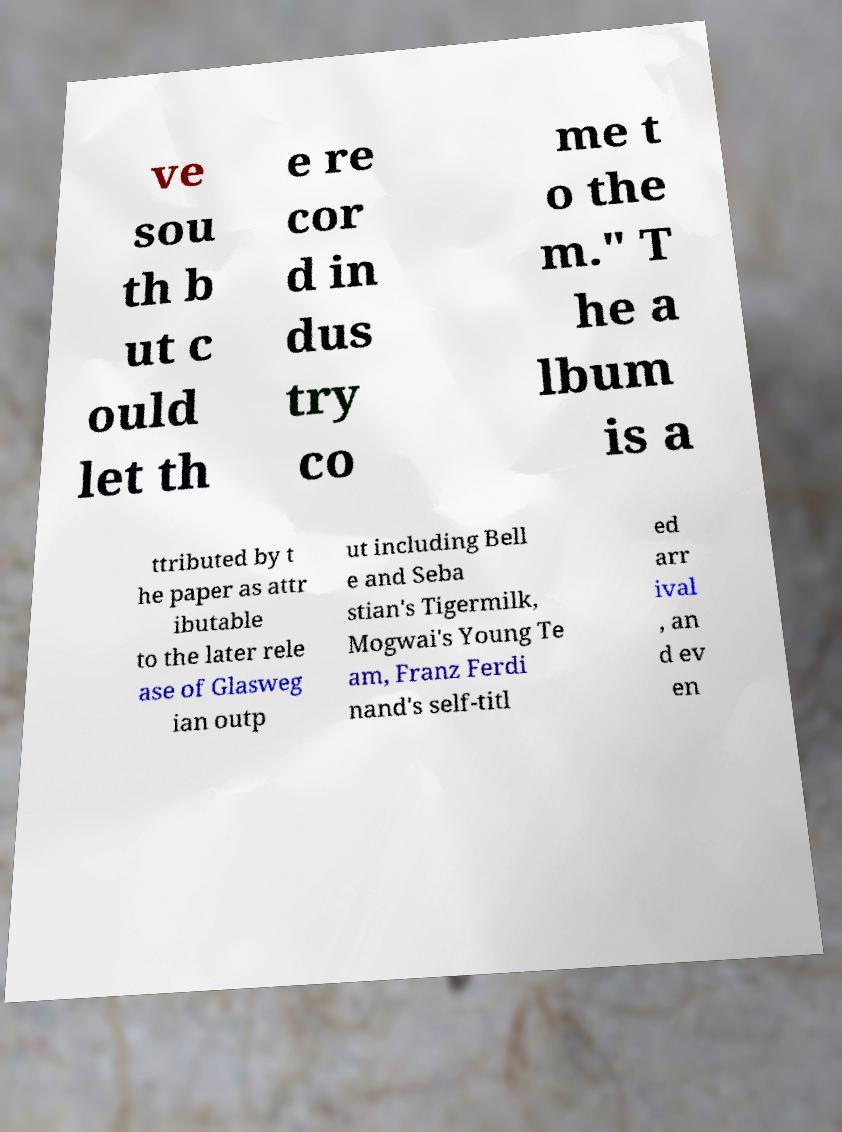Can you accurately transcribe the text from the provided image for me? ve sou th b ut c ould let th e re cor d in dus try co me t o the m." T he a lbum is a ttributed by t he paper as attr ibutable to the later rele ase of Glasweg ian outp ut including Bell e and Seba stian's Tigermilk, Mogwai's Young Te am, Franz Ferdi nand's self-titl ed arr ival , an d ev en 